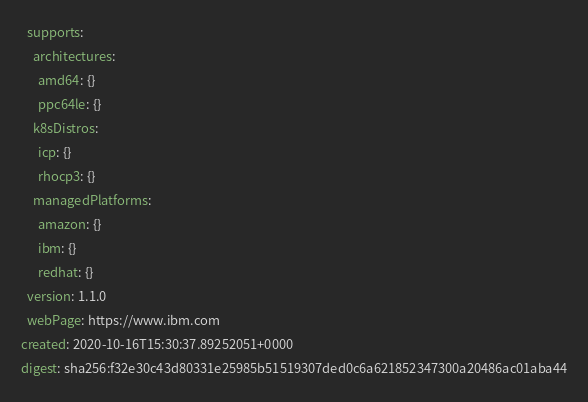Convert code to text. <code><loc_0><loc_0><loc_500><loc_500><_YAML_>  supports:
    architectures:
      amd64: {}
      ppc64le: {}
    k8sDistros:
      icp: {}
      rhocp3: {}
    managedPlatforms:
      amazon: {}
      ibm: {}
      redhat: {}
  version: 1.1.0
  webPage: https://www.ibm.com
created: 2020-10-16T15:30:37.89252051+0000
digest: sha256:f32e30c43d80331e25985b51519307ded0c6a621852347300a20486ac01aba44
</code> 